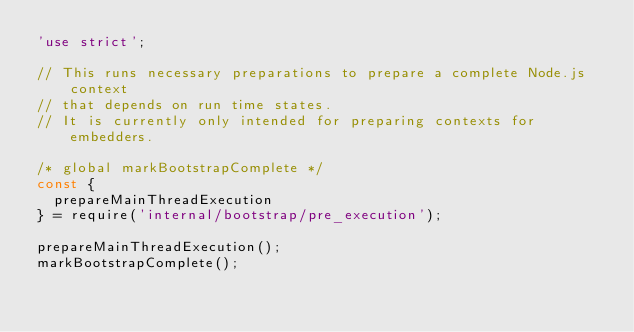Convert code to text. <code><loc_0><loc_0><loc_500><loc_500><_JavaScript_>'use strict';

// This runs necessary preparations to prepare a complete Node.js context
// that depends on run time states.
// It is currently only intended for preparing contexts for embedders.

/* global markBootstrapComplete */
const {
  prepareMainThreadExecution
} = require('internal/bootstrap/pre_execution');

prepareMainThreadExecution();
markBootstrapComplete();
</code> 